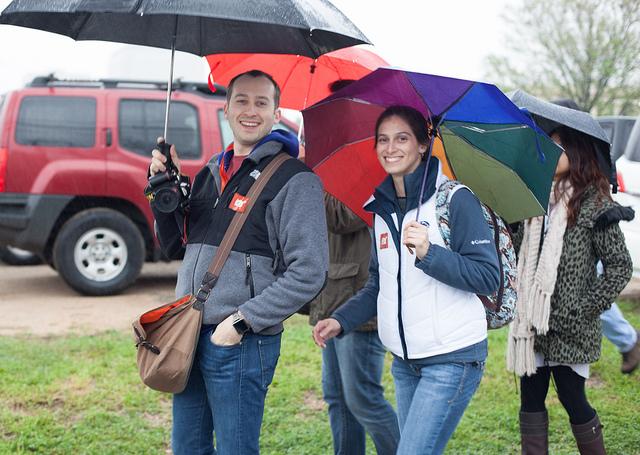What color is the umbrella in the man's right hand?
Keep it brief. Black. Is everyone holding an umbrella?
Write a very short answer. Yes. Are they inside?
Concise answer only. No. Are the man and the woman in the forefront dating?
Keep it brief. Yes. 